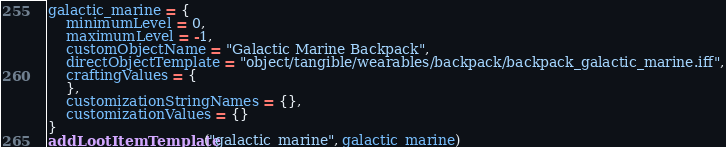Convert code to text. <code><loc_0><loc_0><loc_500><loc_500><_Lua_>galactic_marine = {
	minimumLevel = 0,
	maximumLevel = -1,
	customObjectName = "Galactic Marine Backpack",
	directObjectTemplate = "object/tangible/wearables/backpack/backpack_galactic_marine.iff",
	craftingValues = {
	},
	customizationStringNames = {},
	customizationValues = {}
}
addLootItemTemplate("galactic_marine", galactic_marine)
</code> 